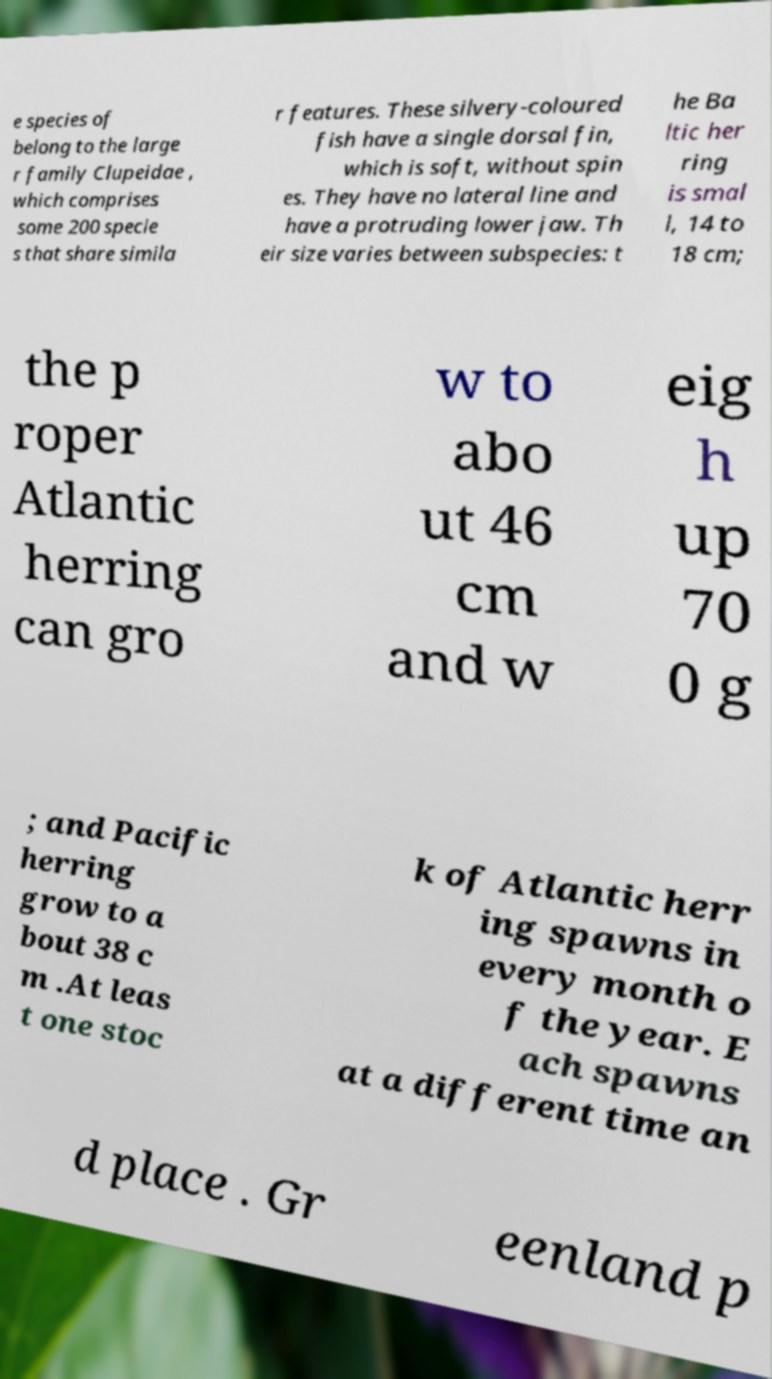Please read and relay the text visible in this image. What does it say? e species of belong to the large r family Clupeidae , which comprises some 200 specie s that share simila r features. These silvery-coloured fish have a single dorsal fin, which is soft, without spin es. They have no lateral line and have a protruding lower jaw. Th eir size varies between subspecies: t he Ba ltic her ring is smal l, 14 to 18 cm; the p roper Atlantic herring can gro w to abo ut 46 cm and w eig h up 70 0 g ; and Pacific herring grow to a bout 38 c m .At leas t one stoc k of Atlantic herr ing spawns in every month o f the year. E ach spawns at a different time an d place . Gr eenland p 